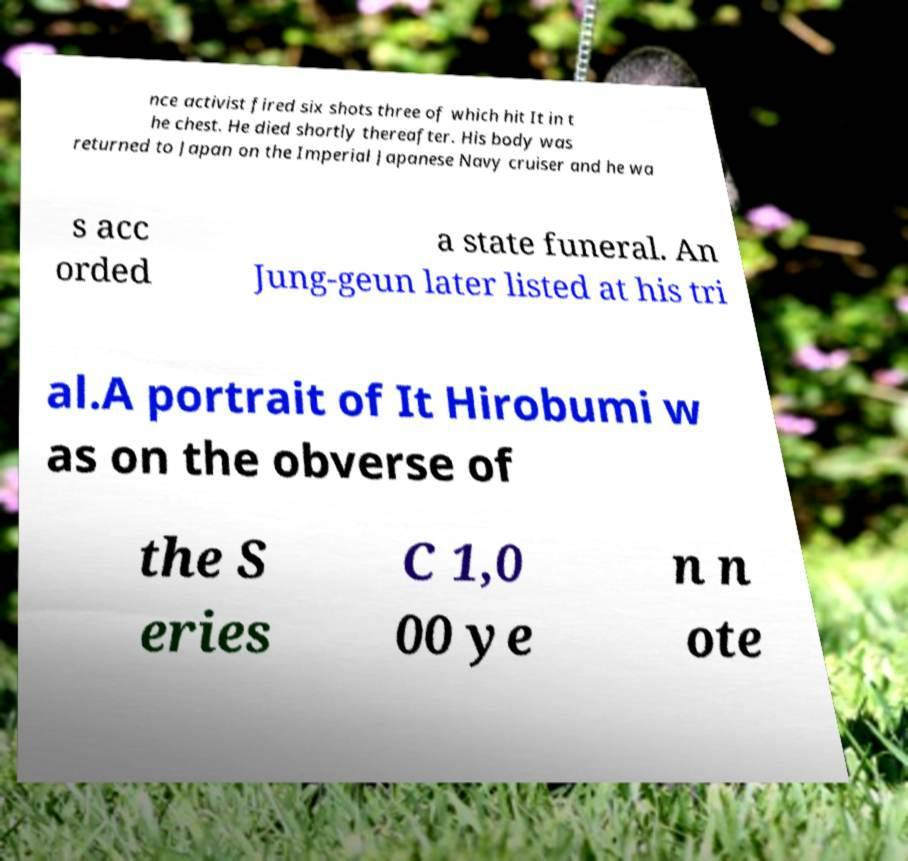Please identify and transcribe the text found in this image. nce activist fired six shots three of which hit It in t he chest. He died shortly thereafter. His body was returned to Japan on the Imperial Japanese Navy cruiser and he wa s acc orded a state funeral. An Jung-geun later listed at his tri al.A portrait of It Hirobumi w as on the obverse of the S eries C 1,0 00 ye n n ote 